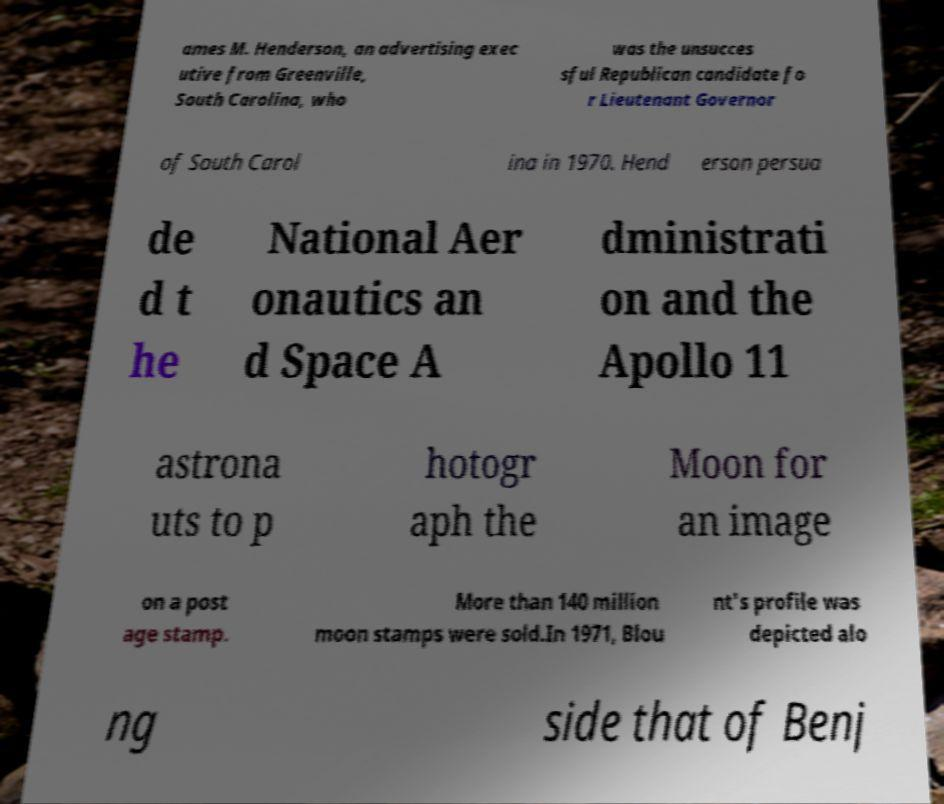I need the written content from this picture converted into text. Can you do that? ames M. Henderson, an advertising exec utive from Greenville, South Carolina, who was the unsucces sful Republican candidate fo r Lieutenant Governor of South Carol ina in 1970. Hend erson persua de d t he National Aer onautics an d Space A dministrati on and the Apollo 11 astrona uts to p hotogr aph the Moon for an image on a post age stamp. More than 140 million moon stamps were sold.In 1971, Blou nt's profile was depicted alo ng side that of Benj 